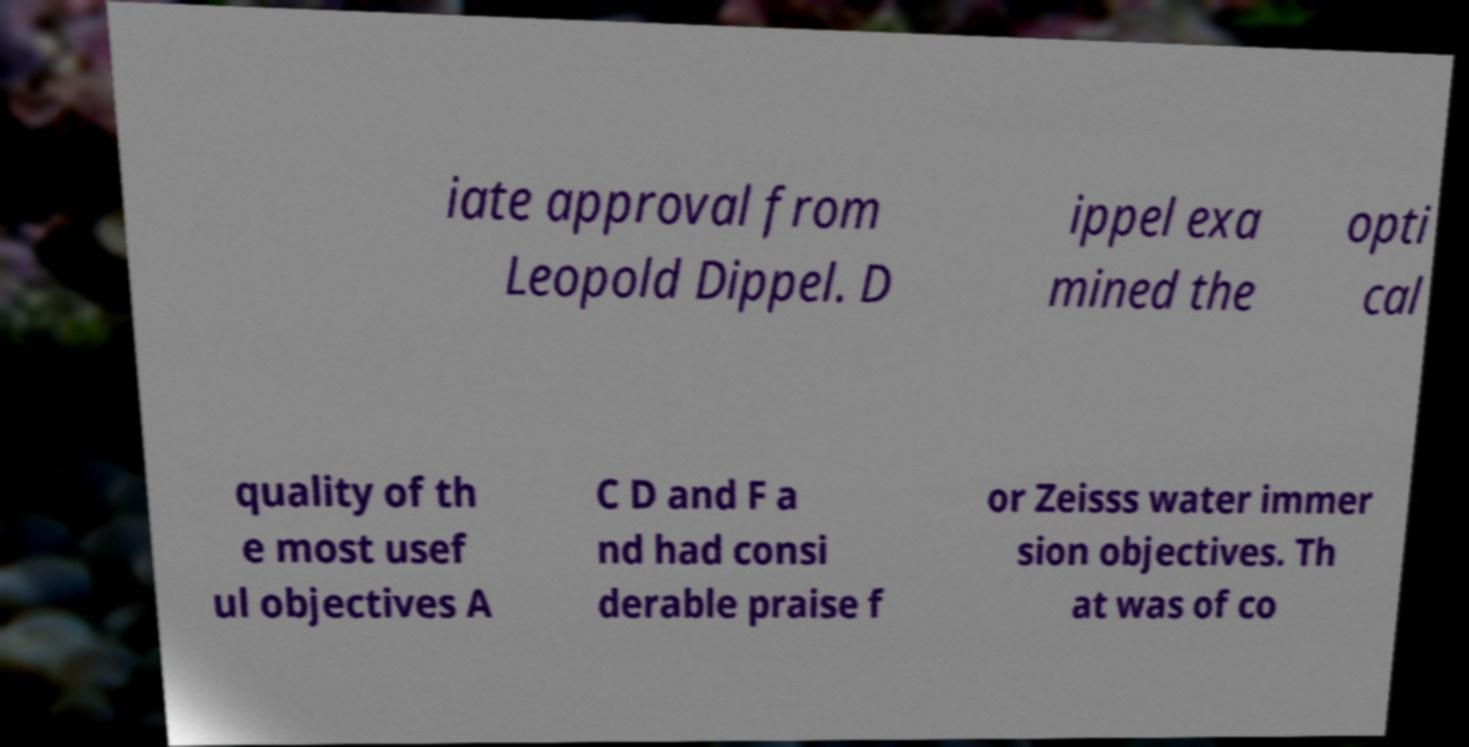Can you read and provide the text displayed in the image?This photo seems to have some interesting text. Can you extract and type it out for me? iate approval from Leopold Dippel. D ippel exa mined the opti cal quality of th e most usef ul objectives A C D and F a nd had consi derable praise f or Zeisss water immer sion objectives. Th at was of co 